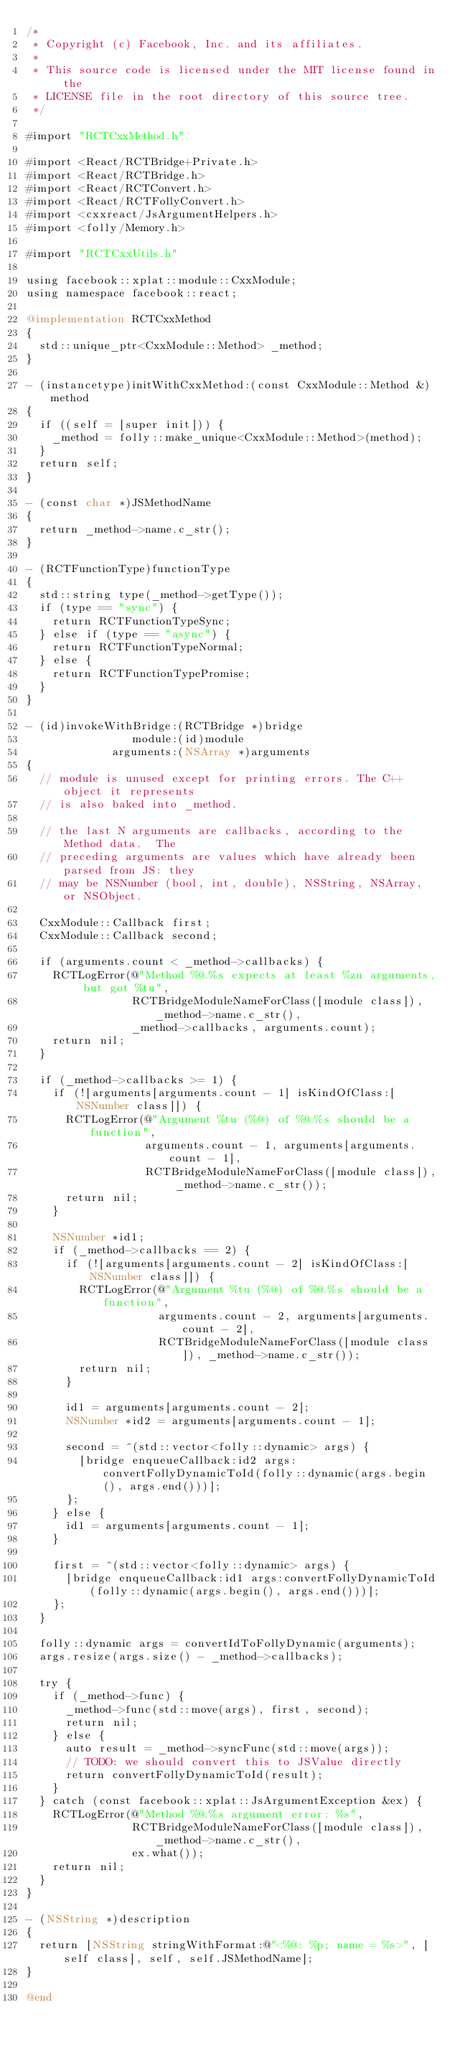<code> <loc_0><loc_0><loc_500><loc_500><_ObjectiveC_>/*
 * Copyright (c) Facebook, Inc. and its affiliates.
 *
 * This source code is licensed under the MIT license found in the
 * LICENSE file in the root directory of this source tree.
 */

#import "RCTCxxMethod.h"

#import <React/RCTBridge+Private.h>
#import <React/RCTBridge.h>
#import <React/RCTConvert.h>
#import <React/RCTFollyConvert.h>
#import <cxxreact/JsArgumentHelpers.h>
#import <folly/Memory.h>

#import "RCTCxxUtils.h"

using facebook::xplat::module::CxxModule;
using namespace facebook::react;

@implementation RCTCxxMethod
{
  std::unique_ptr<CxxModule::Method> _method;
}

- (instancetype)initWithCxxMethod:(const CxxModule::Method &)method
{
  if ((self = [super init])) {
    _method = folly::make_unique<CxxModule::Method>(method);
  }
  return self;
}

- (const char *)JSMethodName
{
  return _method->name.c_str();
}

- (RCTFunctionType)functionType
{
  std::string type(_method->getType());
  if (type == "sync") {
    return RCTFunctionTypeSync;
  } else if (type == "async") {
    return RCTFunctionTypeNormal;
  } else {
    return RCTFunctionTypePromise;
  }
}

- (id)invokeWithBridge:(RCTBridge *)bridge
                module:(id)module
             arguments:(NSArray *)arguments
{
  // module is unused except for printing errors. The C++ object it represents
  // is also baked into _method.

  // the last N arguments are callbacks, according to the Method data.  The
  // preceding arguments are values which have already been parsed from JS: they
  // may be NSNumber (bool, int, double), NSString, NSArray, or NSObject.

  CxxModule::Callback first;
  CxxModule::Callback second;

  if (arguments.count < _method->callbacks) {
    RCTLogError(@"Method %@.%s expects at least %zu arguments, but got %tu",
                RCTBridgeModuleNameForClass([module class]), _method->name.c_str(),
                _method->callbacks, arguments.count);
    return nil;
  }

  if (_method->callbacks >= 1) {
    if (![arguments[arguments.count - 1] isKindOfClass:[NSNumber class]]) {
      RCTLogError(@"Argument %tu (%@) of %@.%s should be a function",
                  arguments.count - 1, arguments[arguments.count - 1],
                  RCTBridgeModuleNameForClass([module class]), _method->name.c_str());
      return nil;
    }

    NSNumber *id1;
    if (_method->callbacks == 2) {
      if (![arguments[arguments.count - 2] isKindOfClass:[NSNumber class]]) {
        RCTLogError(@"Argument %tu (%@) of %@.%s should be a function",
                    arguments.count - 2, arguments[arguments.count - 2],
                    RCTBridgeModuleNameForClass([module class]), _method->name.c_str());
        return nil;
      }

      id1 = arguments[arguments.count - 2];
      NSNumber *id2 = arguments[arguments.count - 1];

      second = ^(std::vector<folly::dynamic> args) {
        [bridge enqueueCallback:id2 args:convertFollyDynamicToId(folly::dynamic(args.begin(), args.end()))];
      };
    } else {
      id1 = arguments[arguments.count - 1];
    }

    first = ^(std::vector<folly::dynamic> args) {
      [bridge enqueueCallback:id1 args:convertFollyDynamicToId(folly::dynamic(args.begin(), args.end()))];
    };
  }

  folly::dynamic args = convertIdToFollyDynamic(arguments);
  args.resize(args.size() - _method->callbacks);

  try {
    if (_method->func) {
      _method->func(std::move(args), first, second);
      return nil;
    } else {
      auto result = _method->syncFunc(std::move(args));
      // TODO: we should convert this to JSValue directly
      return convertFollyDynamicToId(result);
    }
  } catch (const facebook::xplat::JsArgumentException &ex) {
    RCTLogError(@"Method %@.%s argument error: %s",
                RCTBridgeModuleNameForClass([module class]), _method->name.c_str(),
                ex.what());
    return nil;
  }
}

- (NSString *)description
{
  return [NSString stringWithFormat:@"<%@: %p; name = %s>", [self class], self, self.JSMethodName];
}

@end
</code> 